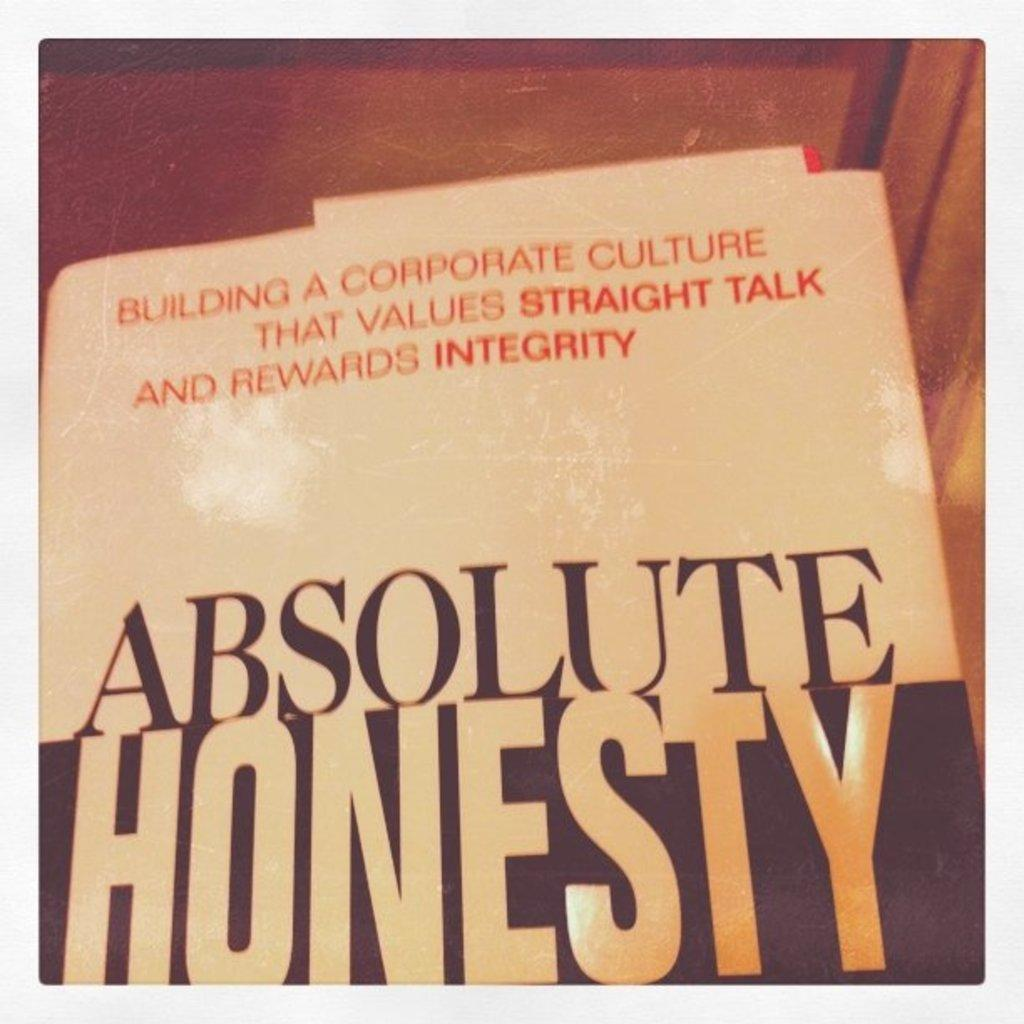<image>
Share a concise interpretation of the image provided. A book with the title Absolute Honesty on it. 